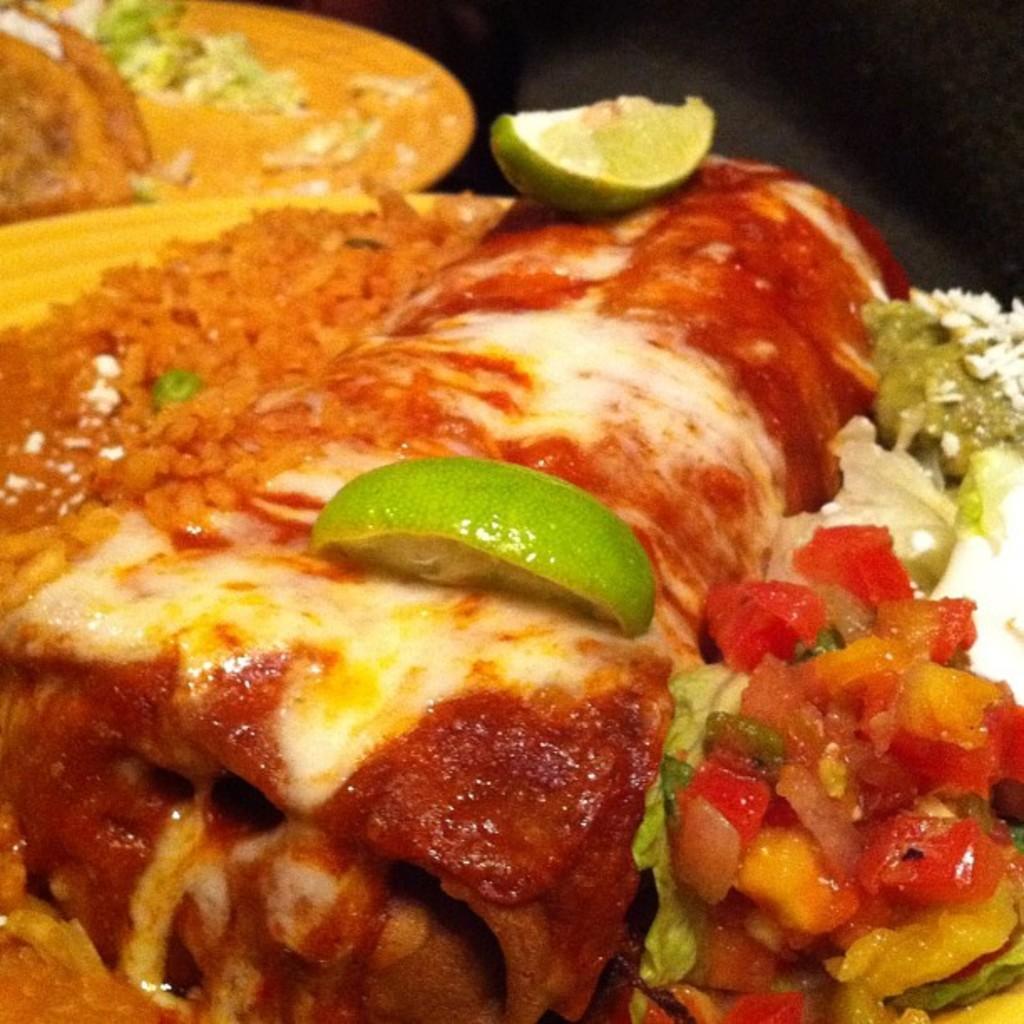Please provide a concise description of this image. In this image we can see the close view of a food item. This part of the image is dark. 